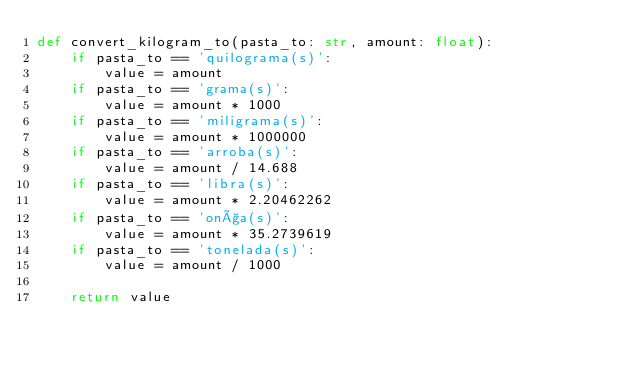Convert code to text. <code><loc_0><loc_0><loc_500><loc_500><_Python_>def convert_kilogram_to(pasta_to: str, amount: float):
    if pasta_to == 'quilograma(s)':
        value = amount
    if pasta_to == 'grama(s)':
        value = amount * 1000
    if pasta_to == 'miligrama(s)':
        value = amount * 1000000
    if pasta_to == 'arroba(s)':
        value = amount / 14.688
    if pasta_to == 'libra(s)':
        value = amount * 2.20462262
    if pasta_to == 'onça(s)':
        value = amount * 35.2739619
    if pasta_to == 'tonelada(s)':
        value = amount / 1000

    return value</code> 